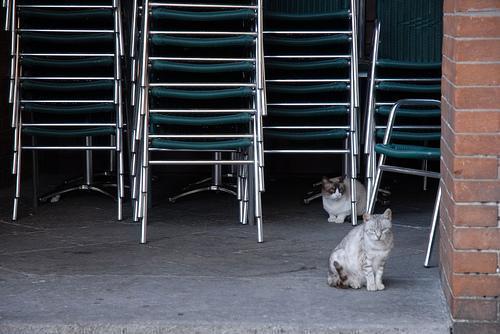If a few more of these animals appear here what would they be called?
Choose the correct response, then elucidate: 'Answer: answer
Rationale: rationale.'
Options: Herd, school, pack, clowder. Answer: clowder.
Rationale: There would be chowder. 